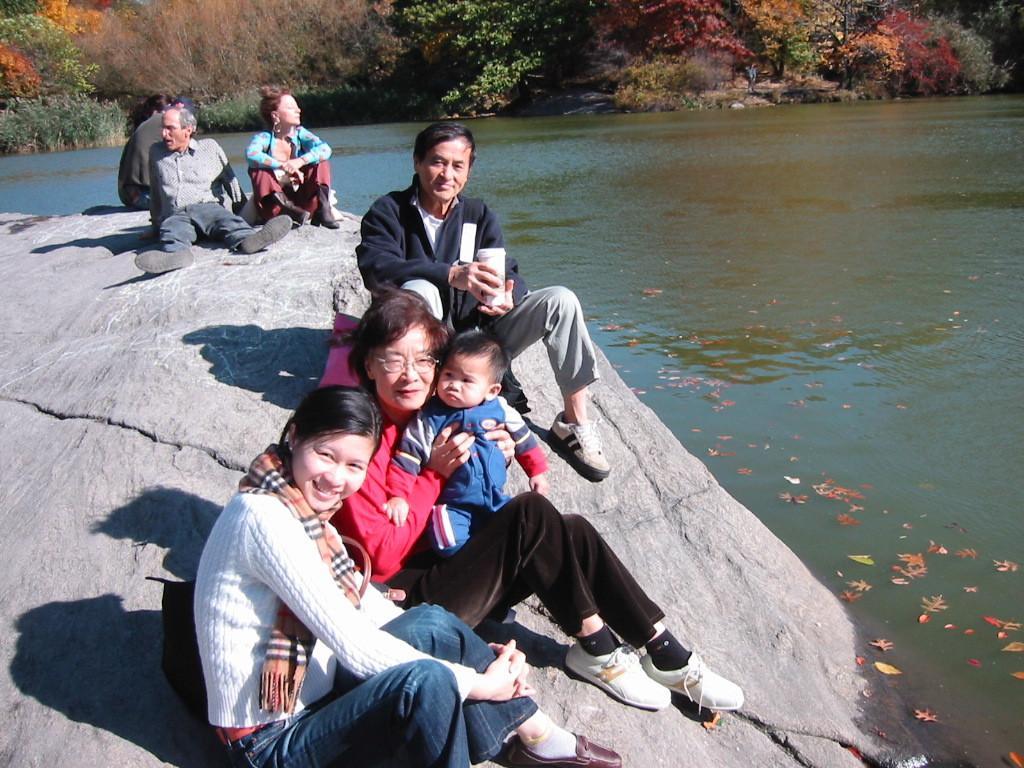Can you describe this image briefly? In this image we can see few persons are sitting on a rock on the left side and a woman is holding kid in her hands. On the right side we can see leave on the water. In the background there are trees and water. 